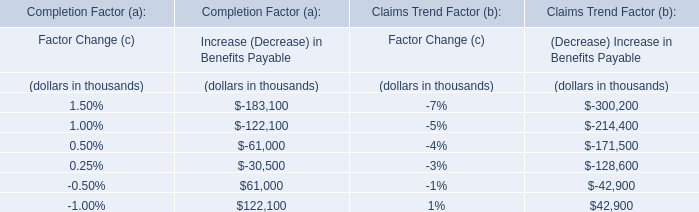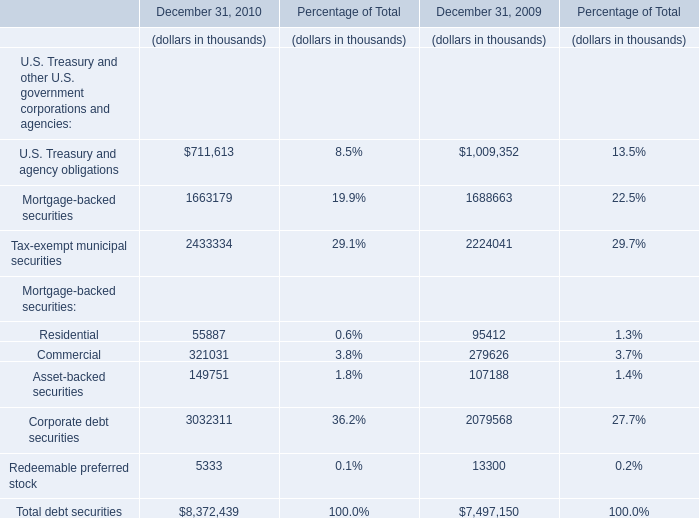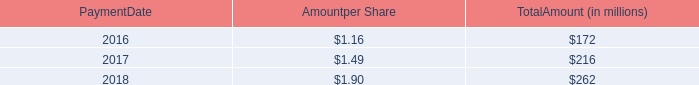on november 2 , 2018 , what was the amount of shares in millions used the calculation of the total dividend payout 
Computations: (68 / 0.50)
Answer: 136.0. 